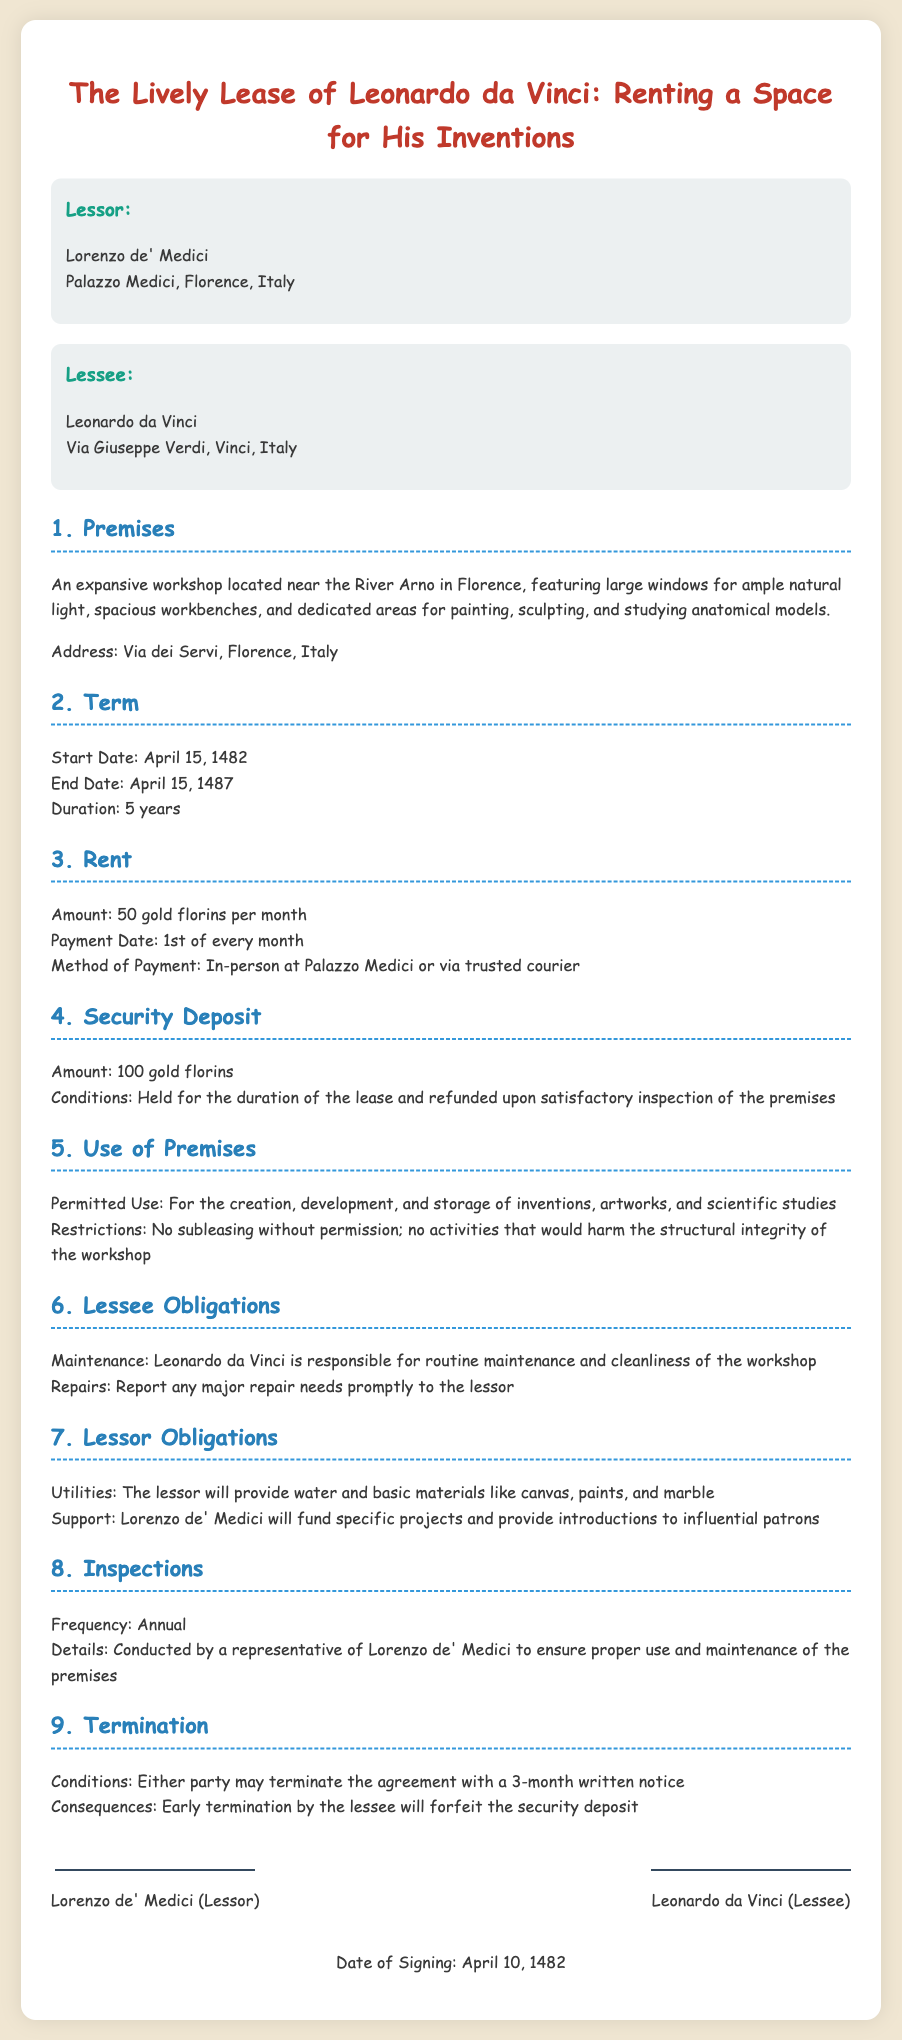What is the name of the lessor? The lessor is Lorenzo de' Medici, who is mentioned at the beginning of the document.
Answer: Lorenzo de' Medici What is the address of the premises? The address of the premises is mentioned in the clause about the premises, specifying the location in Florence.
Answer: Via dei Servi, Florence, Italy What is the duration of the lease? The duration of the lease is outlined in the term clause, which specifies the start and end dates.
Answer: 5 years How much is the rent per month? The rent amount is stated in the rent clause of the document, specifying the monthly payment.
Answer: 50 gold florins What is the security deposit amount? The amount of the security deposit is detailed in the security deposit clause.
Answer: 100 gold florins Who is responsible for maintenance of the workshop? The obligations concerning maintenance are specified in the lessee obligations clause.
Answer: Leonardo da Vinci What type of support will the lessor provide? The lessor's obligations include support, as outlined in the relevant clause about his responsibilities.
Answer: Fund specific projects What is required for termination? The clause regarding termination specifies the conditions needed to end the agreement.
Answer: 3-month written notice How often will inspections occur? The frequency of inspections is specified to ensure proper use and maintenance of the premises.
Answer: Annual 